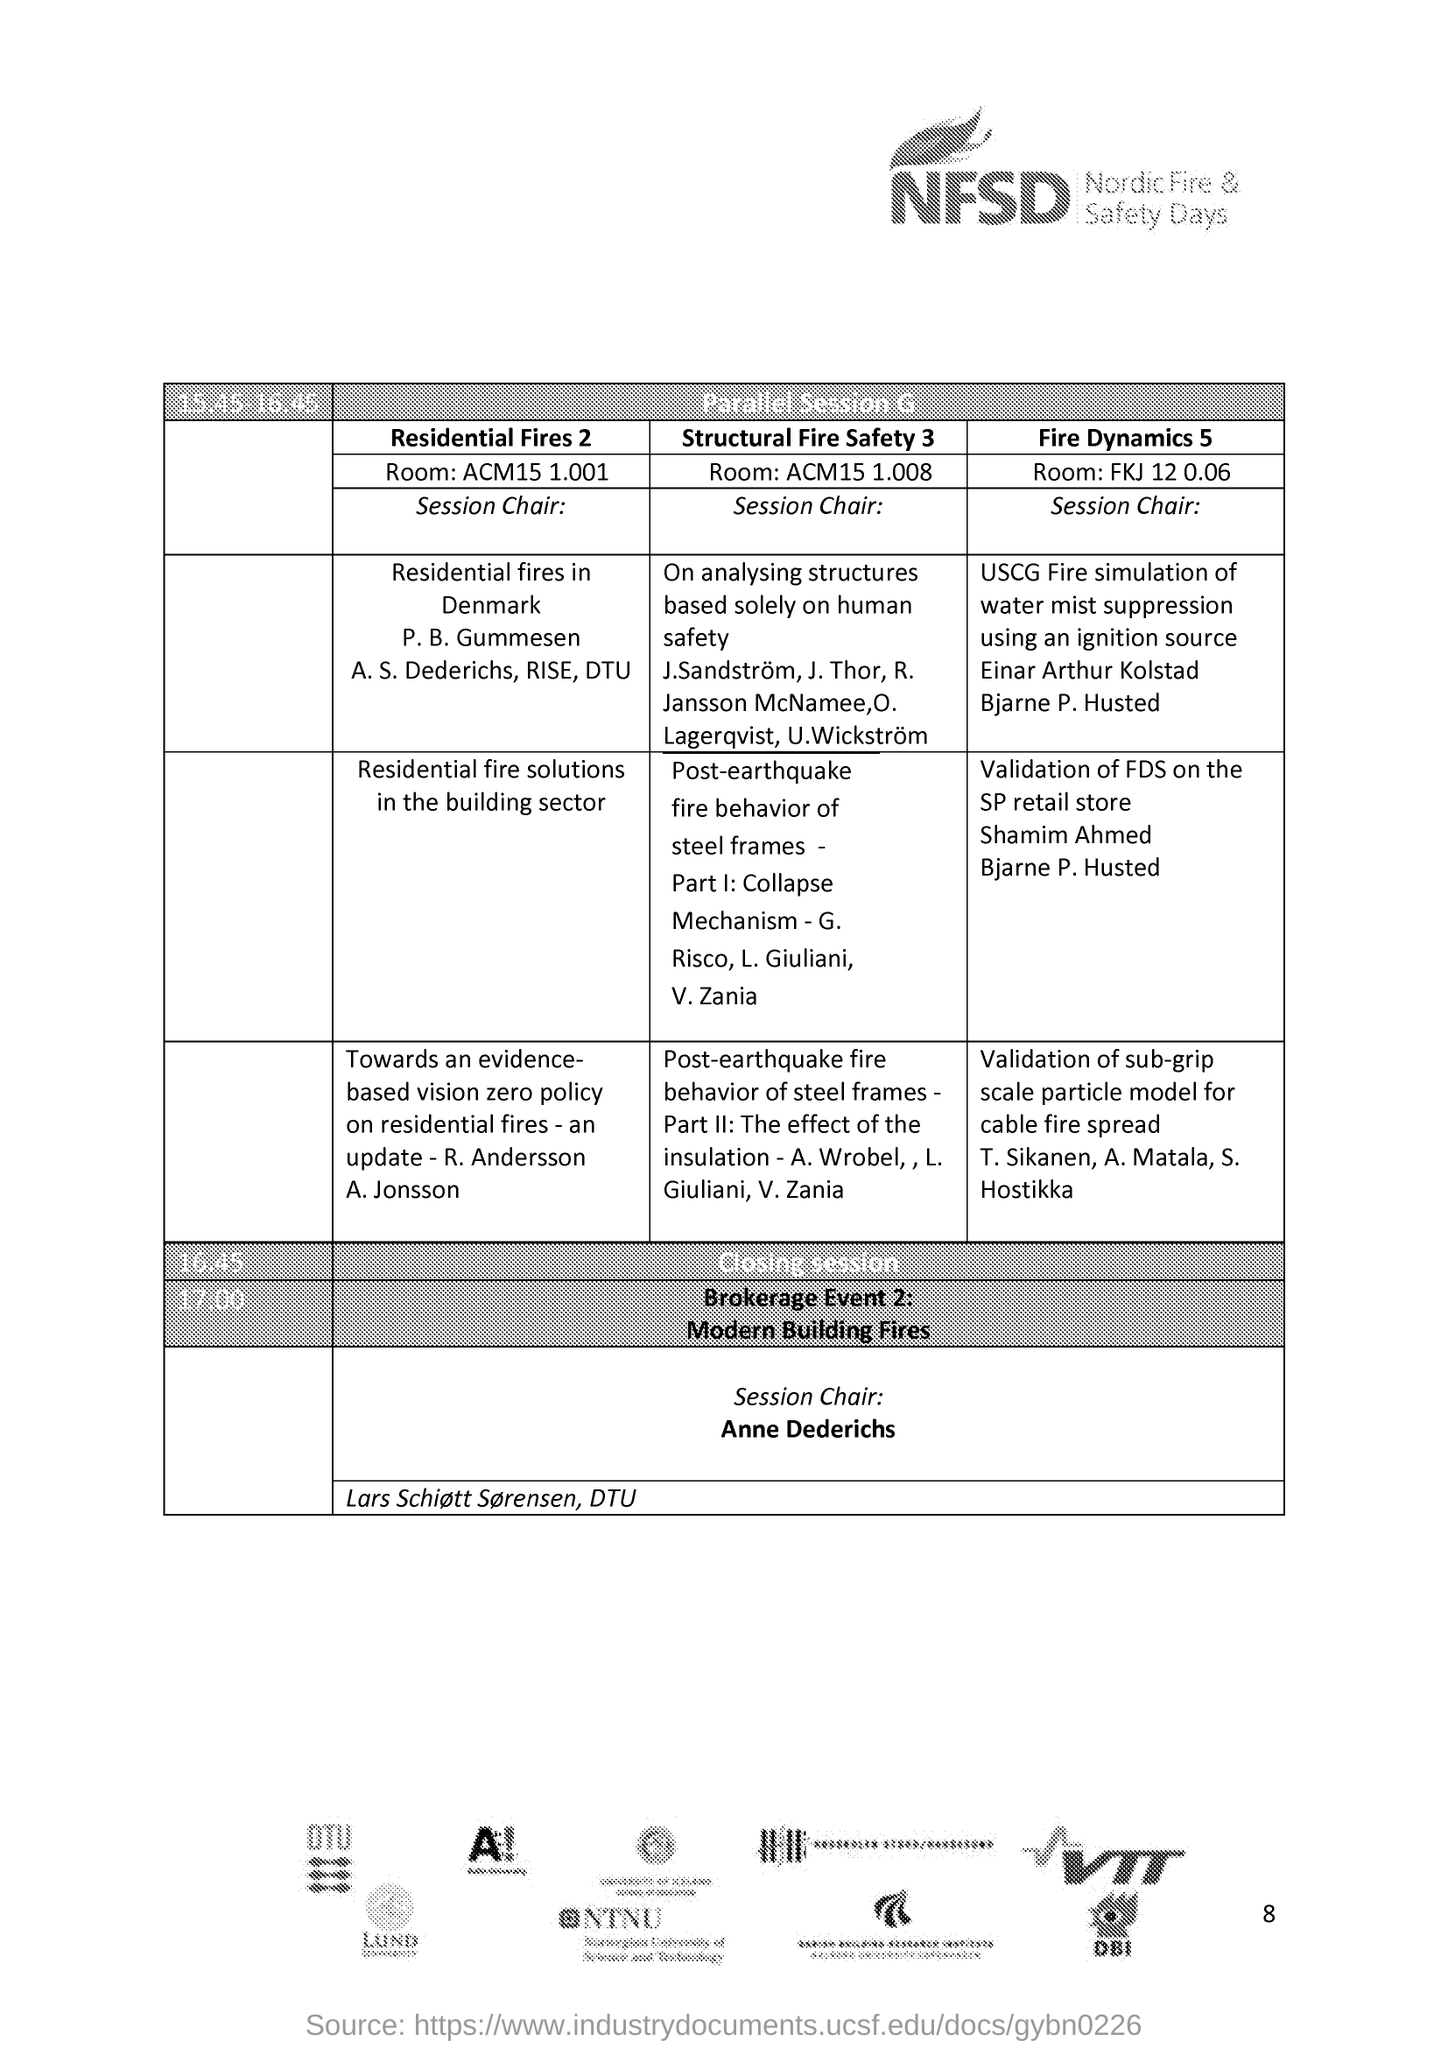What is nfsd?
Ensure brevity in your answer.  Nordic Fire & Safety Days. When does the session end?
Your answer should be compact. 16:45. 